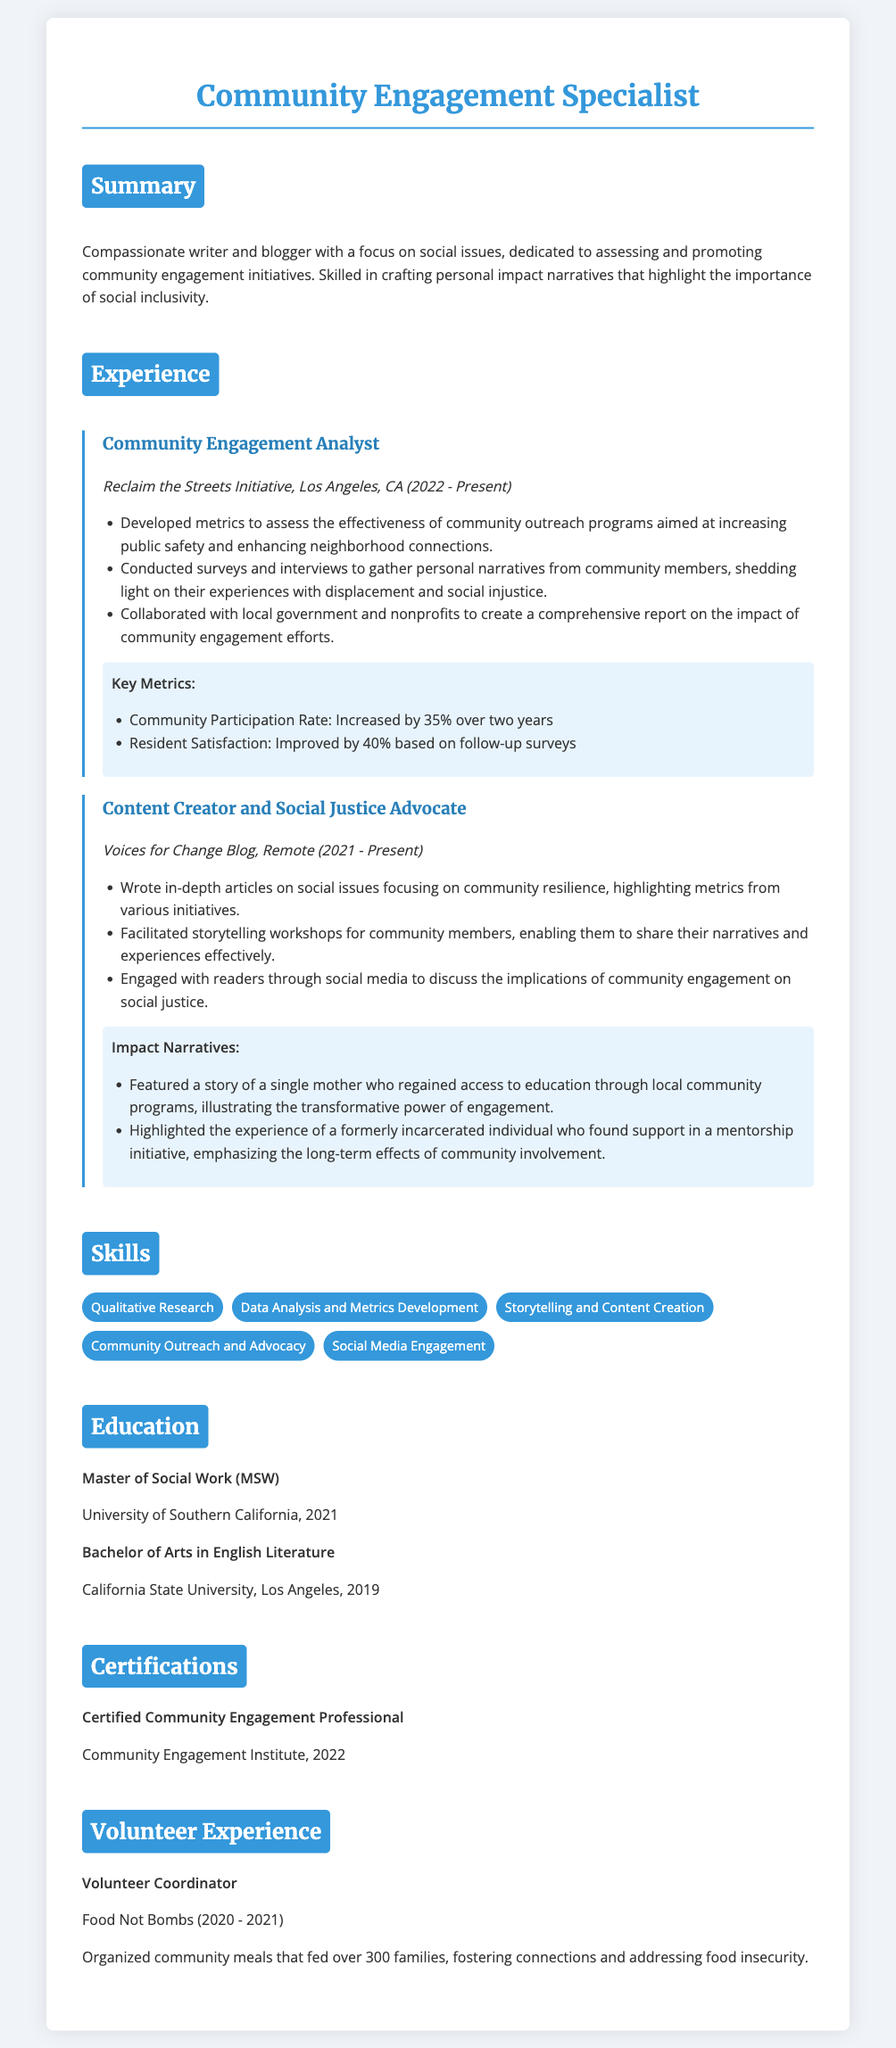What is the job title? The job title is found at the top of the resume, specifically listed under the name of the individual.
Answer: Community Engagement Specialist Which organization is the first experience associated with? The first experience listed in the document includes the organization name and location of where the individual worked.
Answer: Reclaim the Streets Initiative What percentage did community participation increase by? This information is provided under the key metrics section related to community participation.
Answer: 35% What is the Master's degree obtained? The educational background includes specific degrees awarded to the individual, including the Master's degree.
Answer: Master of Social Work What year did the individual complete their Bachelor's degree? The education details mention the year in which the Bachelor's degree was awarded.
Answer: 2019 What type of articles does the individual write? The content of the work done by the individual in their role can be found in the experience section related to writing.
Answer: In-depth articles on social issues Which certification does the individual hold? The certification section lists the specific certification obtained by the individual.
Answer: Certified Community Engagement Professional What was the increase in resident satisfaction? This metric provides insight into the community engagement effectiveness presented in the document.
Answer: 40% What role did the individual hold at Food Not Bombs? The volunteer experience section outlines positions held by the individual in community organizations.
Answer: Volunteer Coordinator What is the focus of the Voices for Change Blog? This is explained in the context of advocacy and the type of content produced by the individual.
Answer: Social justice 